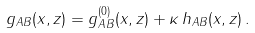Convert formula to latex. <formula><loc_0><loc_0><loc_500><loc_500>g _ { A B } ( x , z ) = g _ { A B } ^ { ( 0 ) } ( x , z ) + \kappa \, h _ { A B } ( x , z ) \, .</formula> 